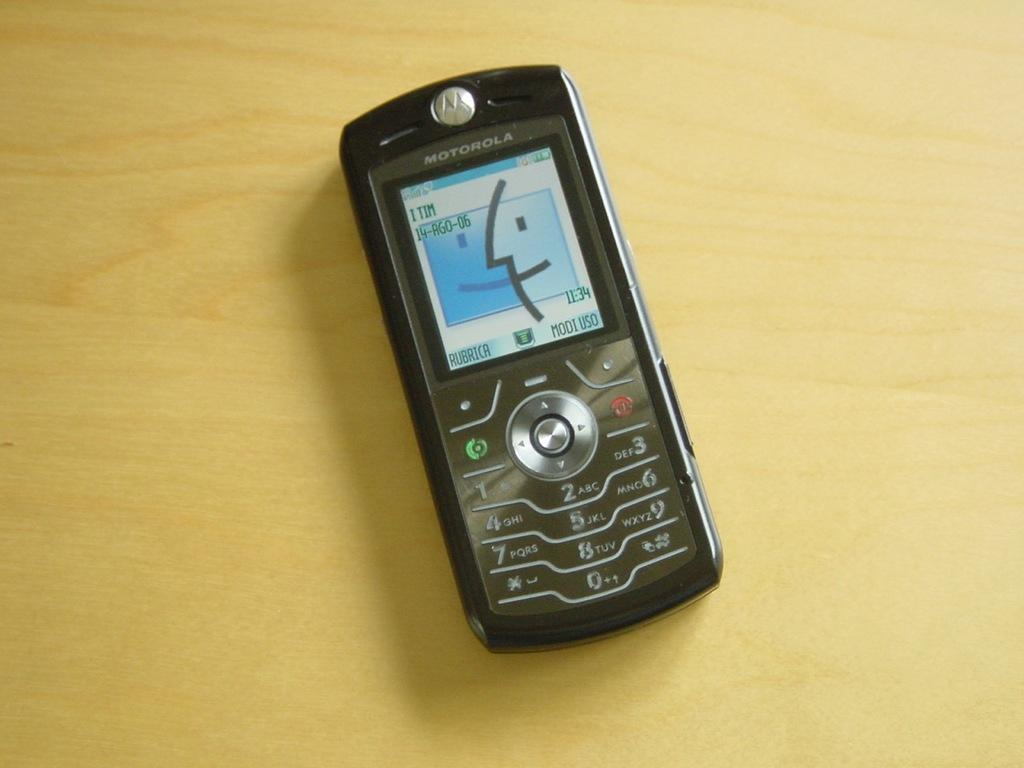<image>
Render a clear and concise summary of the photo. The cell phone shown here is from the company Motorola 